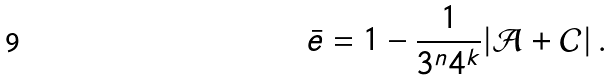<formula> <loc_0><loc_0><loc_500><loc_500>\bar { e } = 1 - \frac { 1 } { 3 ^ { n } 4 ^ { k } } | \mathcal { A } + \mathcal { C } | \, .</formula> 